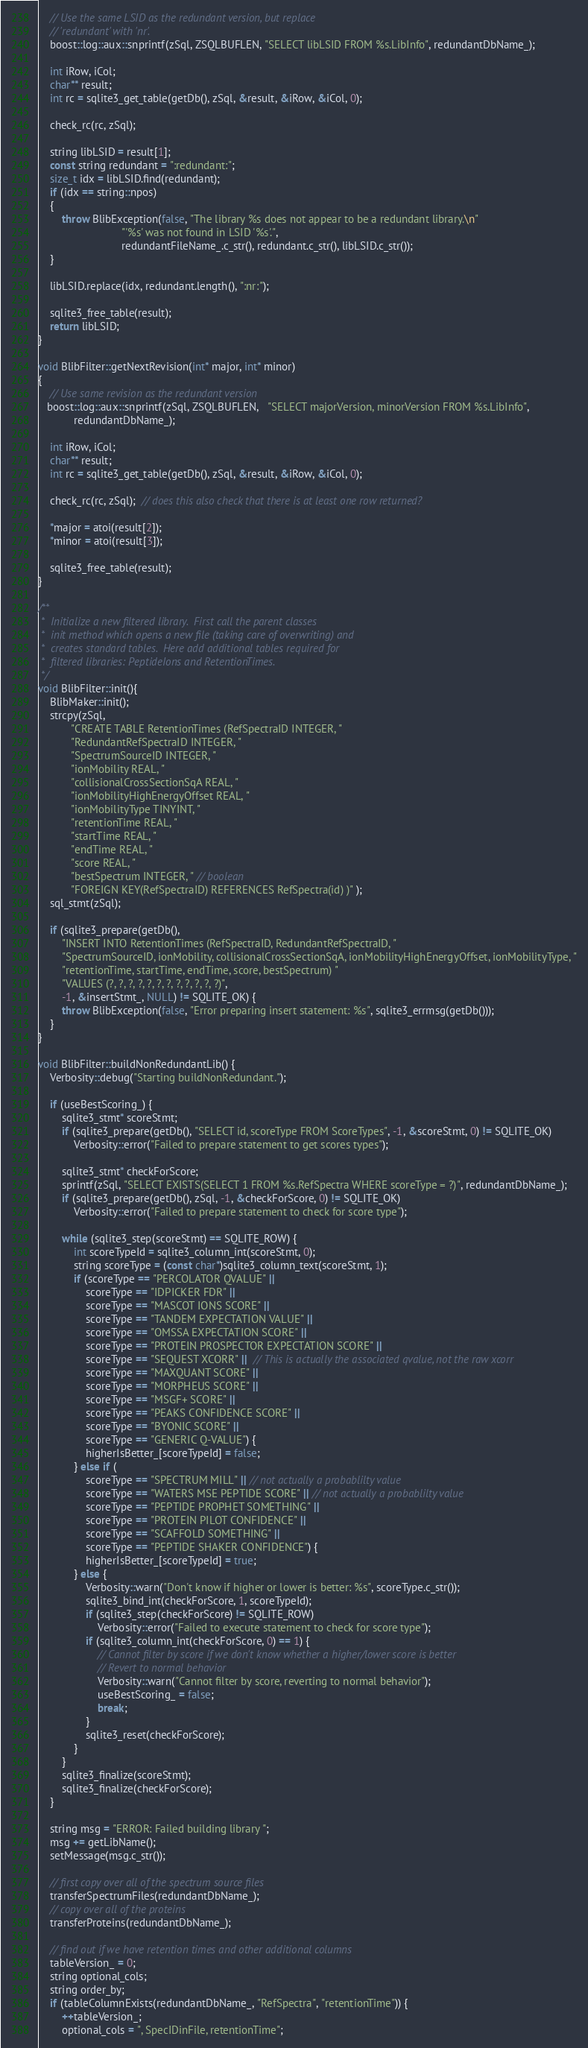<code> <loc_0><loc_0><loc_500><loc_500><_C++_>    // Use the same LSID as the redundant version, but replace
    // 'redundant' with 'nr'.
    boost::log::aux::snprintf(zSql, ZSQLBUFLEN, "SELECT libLSID FROM %s.LibInfo", redundantDbName_);
    
    int iRow, iCol;
    char** result;
    int rc = sqlite3_get_table(getDb(), zSql, &result, &iRow, &iCol, 0);
    
    check_rc(rc, zSql);
    
    string libLSID = result[1];
    const string redundant = ":redundant:";
    size_t idx = libLSID.find(redundant);
    if (idx == string::npos)
    {
        throw BlibException(false, "The library %s does not appear to be a redundant library.\n"
                            "'%s' was not found in LSID '%s'.",
                            redundantFileName_.c_str(), redundant.c_str(), libLSID.c_str());
    }

    libLSID.replace(idx, redundant.length(), ":nr:");
    
    sqlite3_free_table(result);
    return libLSID;
}

void BlibFilter::getNextRevision(int* major, int* minor)
{
    // Use same revision as the redundant version
   boost::log::aux::snprintf(zSql, ZSQLBUFLEN,   "SELECT majorVersion, minorVersion FROM %s.LibInfo", 
            redundantDbName_);
    
    int iRow, iCol;
    char** result;
    int rc = sqlite3_get_table(getDb(), zSql, &result, &iRow, &iCol, 0);
    
    check_rc(rc, zSql);  // does this also check that there is at least one row returned?
    
    *major = atoi(result[2]);
    *minor = atoi(result[3]);
    
    sqlite3_free_table(result);
}

/**
 *  Initialize a new filtered library.  First call the parent classes
 *  init method which opens a new file (taking care of overwriting) and
 *  creates standard tables.  Here add additional tables required for
 *  filtered libraries: PeptideIons and RetentionTimes.
 */
void BlibFilter::init(){
    BlibMaker::init();
    strcpy(zSql,
           "CREATE TABLE RetentionTimes (RefSpectraID INTEGER, "
           "RedundantRefSpectraID INTEGER, "
           "SpectrumSourceID INTEGER, "
           "ionMobility REAL, "
           "collisionalCrossSectionSqA REAL, "
           "ionMobilityHighEnergyOffset REAL, "
           "ionMobilityType TINYINT, "
           "retentionTime REAL, "
           "startTime REAL, "
           "endTime REAL, "
           "score REAL, "
           "bestSpectrum INTEGER, " // boolean
           "FOREIGN KEY(RefSpectraID) REFERENCES RefSpectra(id) )" );
    sql_stmt(zSql);

    if (sqlite3_prepare(getDb(),
        "INSERT INTO RetentionTimes (RefSpectraID, RedundantRefSpectraID, "
        "SpectrumSourceID, ionMobility, collisionalCrossSectionSqA, ionMobilityHighEnergyOffset, ionMobilityType, "
        "retentionTime, startTime, endTime, score, bestSpectrum) "
        "VALUES (?, ?, ?, ?, ?, ?, ?, ?, ?, ?, ?, ?)",
        -1, &insertStmt_, NULL) != SQLITE_OK) {
        throw BlibException(false, "Error preparing insert statement: %s", sqlite3_errmsg(getDb()));
    }
}

void BlibFilter::buildNonRedundantLib() {
    Verbosity::debug("Starting buildNonRedundant.");

    if (useBestScoring_) {
        sqlite3_stmt* scoreStmt;
        if (sqlite3_prepare(getDb(), "SELECT id, scoreType FROM ScoreTypes", -1, &scoreStmt, 0) != SQLITE_OK)
            Verbosity::error("Failed to prepare statement to get scores types");
        
        sqlite3_stmt* checkForScore;
        sprintf(zSql, "SELECT EXISTS(SELECT 1 FROM %s.RefSpectra WHERE scoreType = ?)", redundantDbName_);
        if (sqlite3_prepare(getDb(), zSql, -1, &checkForScore, 0) != SQLITE_OK)
            Verbosity::error("Failed to prepare statement to check for score type");

        while (sqlite3_step(scoreStmt) == SQLITE_ROW) {
            int scoreTypeId = sqlite3_column_int(scoreStmt, 0);
            string scoreType = (const char*)sqlite3_column_text(scoreStmt, 1);
            if (scoreType == "PERCOLATOR QVALUE" ||
                scoreType == "IDPICKER FDR" ||
                scoreType == "MASCOT IONS SCORE" ||
                scoreType == "TANDEM EXPECTATION VALUE" ||
                scoreType == "OMSSA EXPECTATION SCORE" ||
                scoreType == "PROTEIN PROSPECTOR EXPECTATION SCORE" ||
                scoreType == "SEQUEST XCORR" ||  // This is actually the associated qvalue, not the raw xcorr
                scoreType == "MAXQUANT SCORE" ||
                scoreType == "MORPHEUS SCORE" ||
                scoreType == "MSGF+ SCORE" ||
                scoreType == "PEAKS CONFIDENCE SCORE" ||
                scoreType == "BYONIC SCORE" ||
                scoreType == "GENERIC Q-VALUE") {
                higherIsBetter_[scoreTypeId] = false;
            } else if (
                scoreType == "SPECTRUM MILL" || // not actually a probablilty value
                scoreType == "WATERS MSE PEPTIDE SCORE" || // not actually a probablilty value
                scoreType == "PEPTIDE PROPHET SOMETHING" ||
                scoreType == "PROTEIN PILOT CONFIDENCE" ||
                scoreType == "SCAFFOLD SOMETHING" ||
                scoreType == "PEPTIDE SHAKER CONFIDENCE") {
                higherIsBetter_[scoreTypeId] = true;
            } else {
                Verbosity::warn("Don't know if higher or lower is better: %s", scoreType.c_str());
                sqlite3_bind_int(checkForScore, 1, scoreTypeId);
                if (sqlite3_step(checkForScore) != SQLITE_ROW)
                    Verbosity::error("Failed to execute statement to check for score type");
                if (sqlite3_column_int(checkForScore, 0) == 1) {
                    // Cannot filter by score if we don't know whether a higher/lower score is better
                    // Revert to normal behavior
                    Verbosity::warn("Cannot filter by score, reverting to normal behavior");
                    useBestScoring_ = false;
                    break;
                }
                sqlite3_reset(checkForScore);
            }
        }
        sqlite3_finalize(scoreStmt);
        sqlite3_finalize(checkForScore);
    }

    string msg = "ERROR: Failed building library ";
    msg += getLibName();
    setMessage(msg.c_str());

    // first copy over all of the spectrum source files
    transferSpectrumFiles(redundantDbName_);
    // copy over all of the proteins
    transferProteins(redundantDbName_);

    // find out if we have retention times and other additional columns
    tableVersion_ = 0;
    string optional_cols;
    string order_by;
    if (tableColumnExists(redundantDbName_, "RefSpectra", "retentionTime")) {
        ++tableVersion_;
        optional_cols = ", SpecIDinFile, retentionTime";</code> 